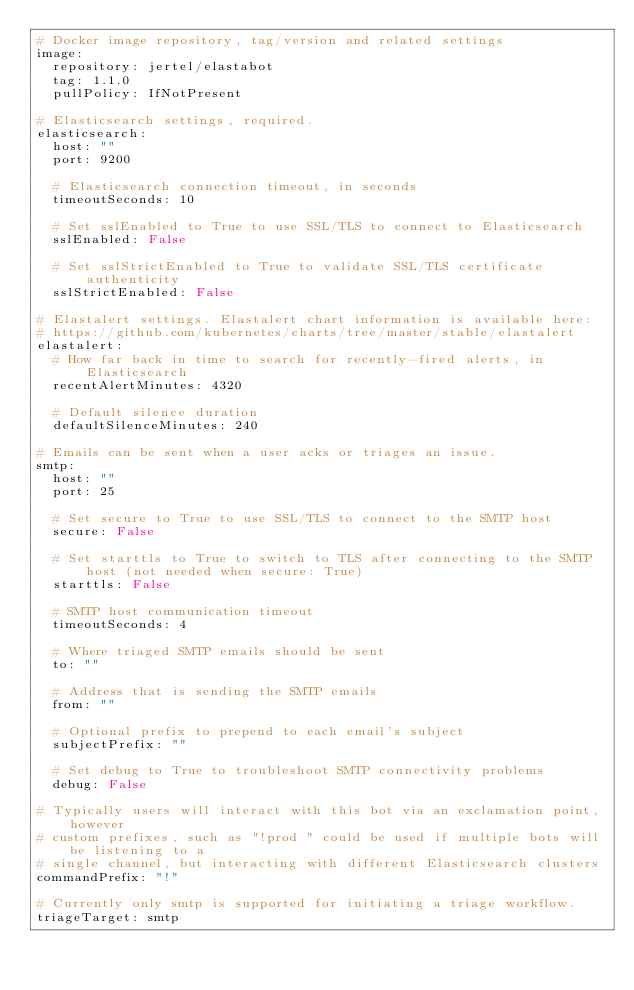<code> <loc_0><loc_0><loc_500><loc_500><_YAML_># Docker image repository, tag/version and related settings
image:
  repository: jertel/elastabot
  tag: 1.1.0
  pullPolicy: IfNotPresent

# Elasticsearch settings, required.
elasticsearch:
  host: ""
  port: 9200

  # Elasticsearch connection timeout, in seconds
  timeoutSeconds: 10

  # Set sslEnabled to True to use SSL/TLS to connect to Elasticsearch
  sslEnabled: False

  # Set sslStrictEnabled to True to validate SSL/TLS certificate authenticity
  sslStrictEnabled: False

# Elastalert settings. Elastalert chart information is available here:
# https://github.com/kubernetes/charts/tree/master/stable/elastalert
elastalert:
  # How far back in time to search for recently-fired alerts, in Elasticsearch
  recentAlertMinutes: 4320

  # Default silence duration
  defaultSilenceMinutes: 240

# Emails can be sent when a user acks or triages an issue.
smtp:
  host: ""
  port: 25

  # Set secure to True to use SSL/TLS to connect to the SMTP host
  secure: False

  # Set starttls to True to switch to TLS after connecting to the SMTP host (not needed when secure: True)
  starttls: False

  # SMTP host communication timeout
  timeoutSeconds: 4

  # Where triaged SMTP emails should be sent
  to: ""

  # Address that is sending the SMTP emails
  from: ""

  # Optional prefix to prepend to each email's subject
  subjectPrefix: ""

  # Set debug to True to troubleshoot SMTP connectivity problems
  debug: False

# Typically users will interact with this bot via an exclamation point, however
# custom prefixes, such as "!prod " could be used if multiple bots will be listening to a
# single channel, but interacting with different Elasticsearch clusters
commandPrefix: "!"

# Currently only smtp is supported for initiating a triage workflow.
triageTarget: smtp
</code> 